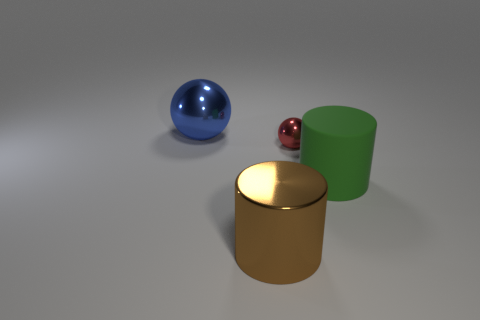Looking at the positioning of these objects, can you infer any particular pattern or relationship? The objects are arranged with clear space between them, suggesting intentional placement for display or comparative purposes. There's no specific pattern, but the spacing implies a deliberate organization. 